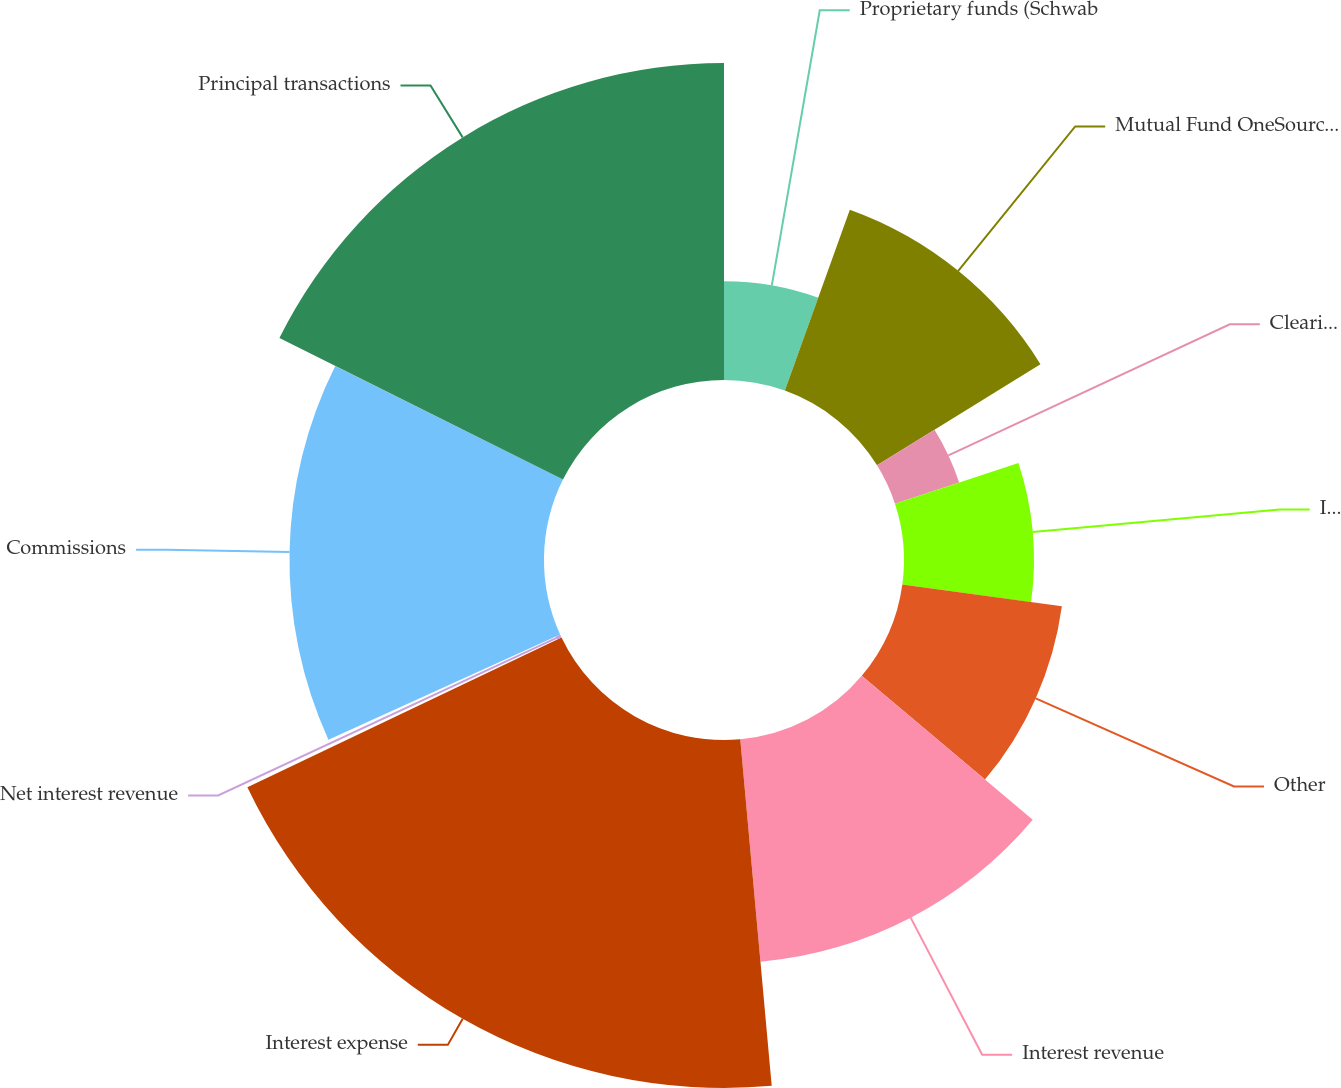Convert chart to OTSL. <chart><loc_0><loc_0><loc_500><loc_500><pie_chart><fcel>Proprietary funds (Schwab<fcel>Mutual Fund OneSource <fcel>Clearing and other<fcel>Investment management and<fcel>Other<fcel>Interest revenue<fcel>Interest expense<fcel>Net interest revenue<fcel>Commissions<fcel>Principal transactions<nl><fcel>5.49%<fcel>10.69%<fcel>3.76%<fcel>7.23%<fcel>8.96%<fcel>12.43%<fcel>19.36%<fcel>0.29%<fcel>14.16%<fcel>17.63%<nl></chart> 